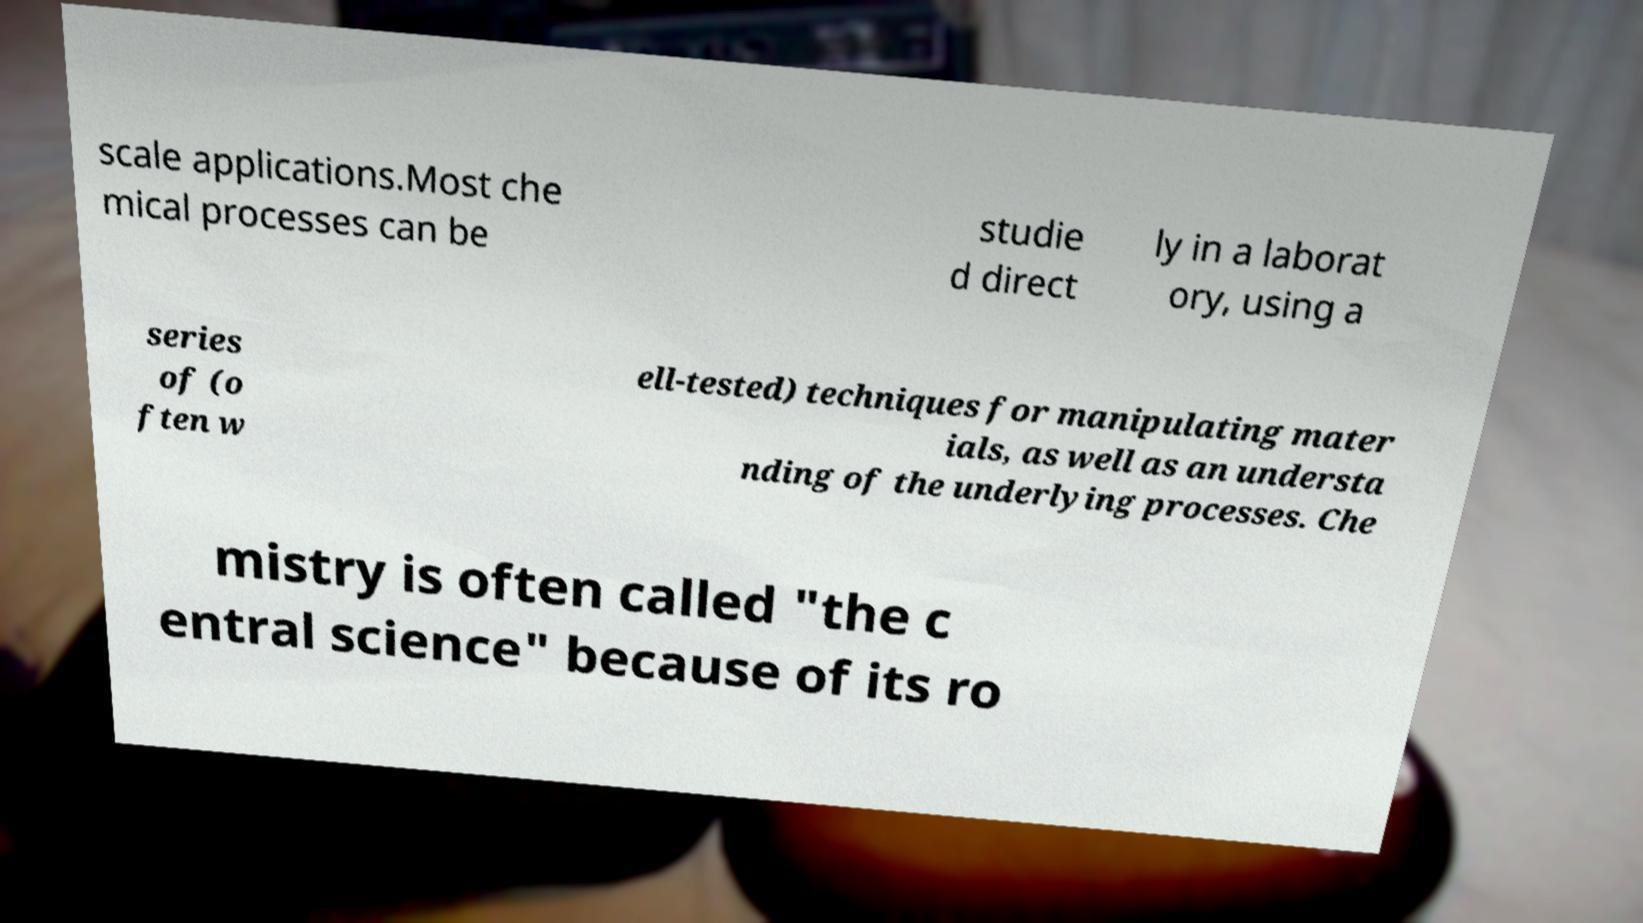Can you read and provide the text displayed in the image?This photo seems to have some interesting text. Can you extract and type it out for me? scale applications.Most che mical processes can be studie d direct ly in a laborat ory, using a series of (o ften w ell-tested) techniques for manipulating mater ials, as well as an understa nding of the underlying processes. Che mistry is often called "the c entral science" because of its ro 